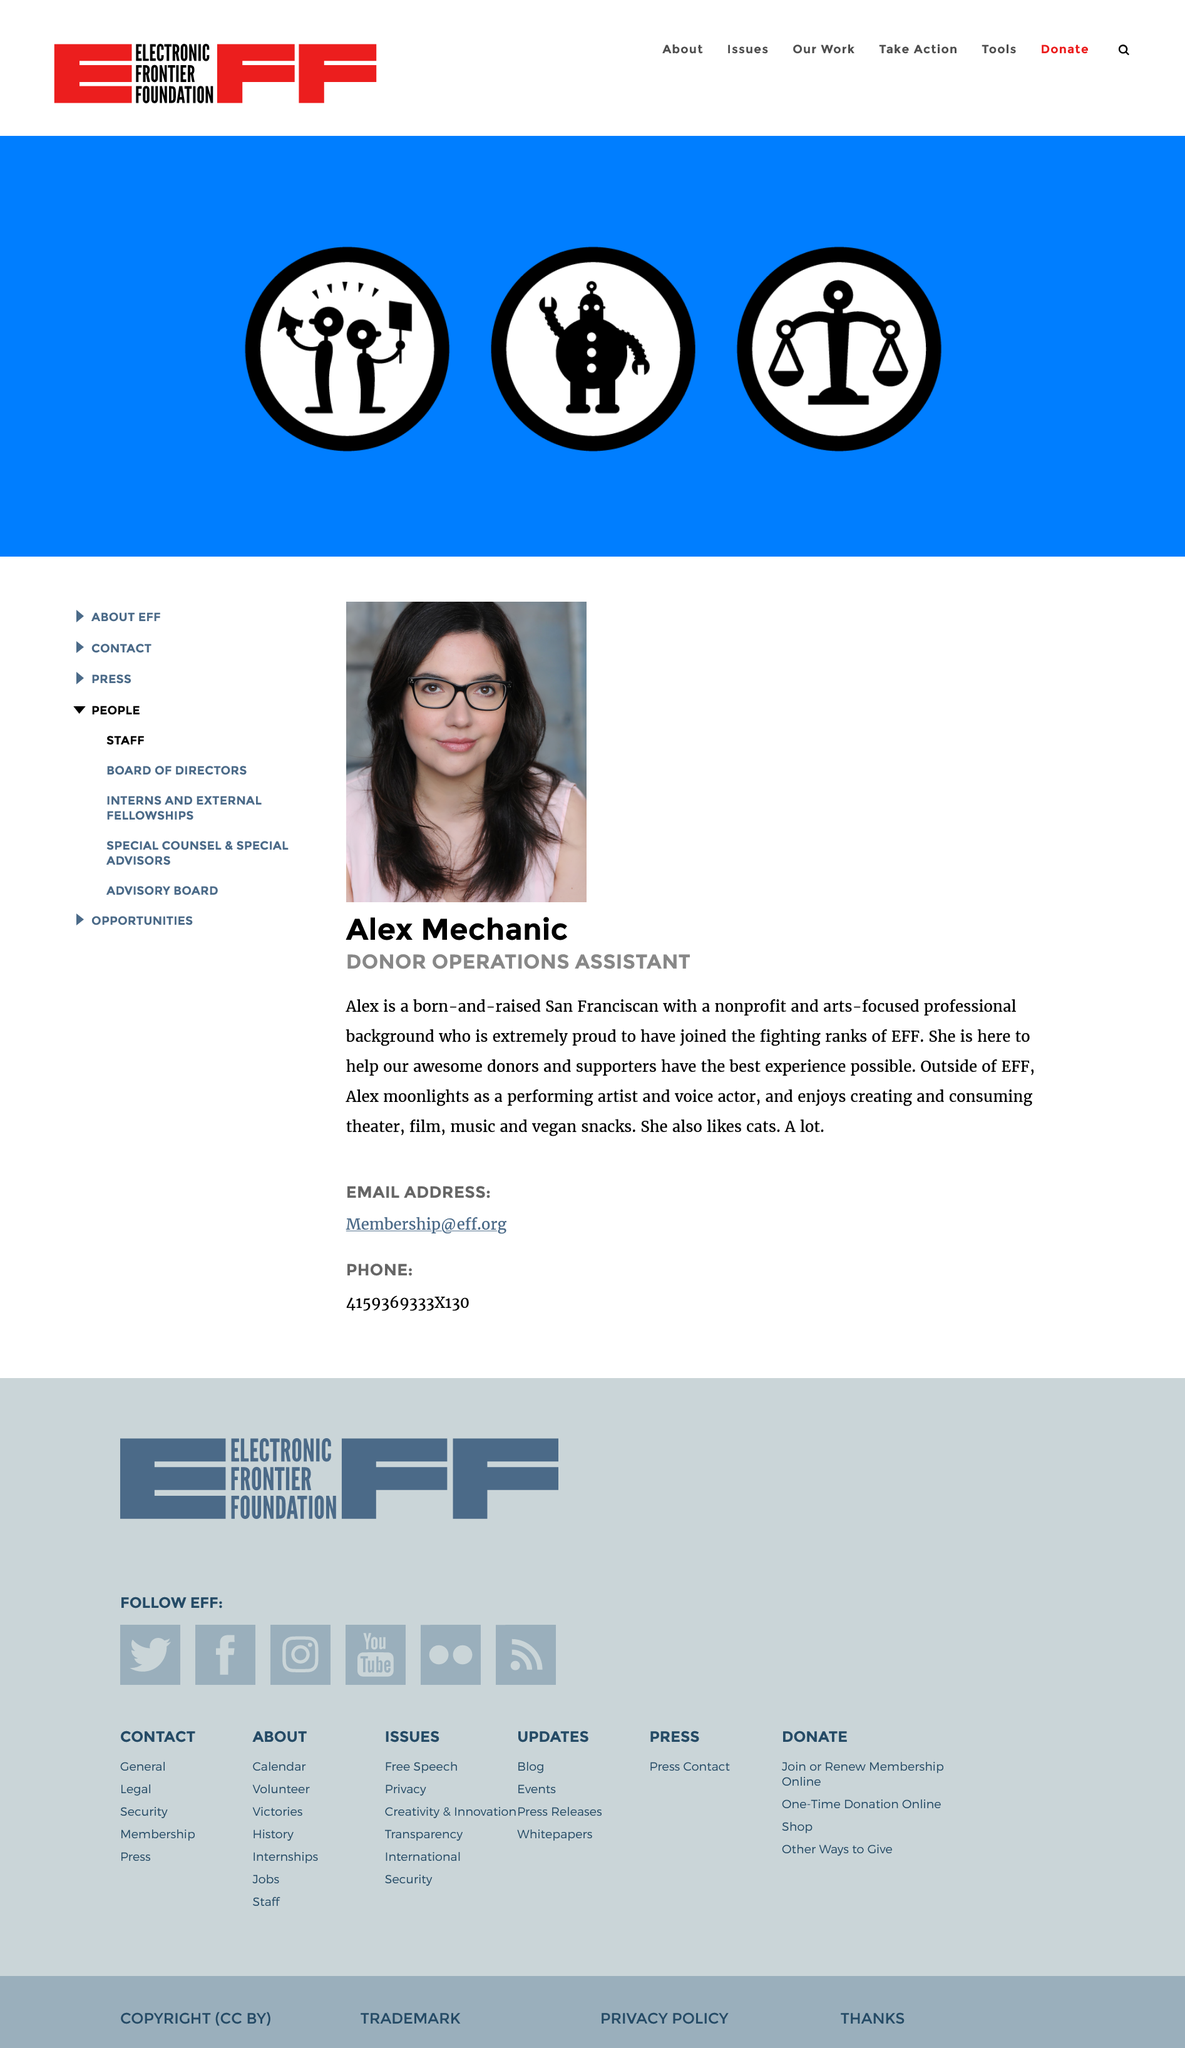Outline some significant characteristics in this image. Alex Mechanic was born and raised in San Francisco. Alex Mechanic is the donor operations assistant at the Electronic Frontier Foundation (EFF). Alex Mechanic's favorite animal is a cat. 